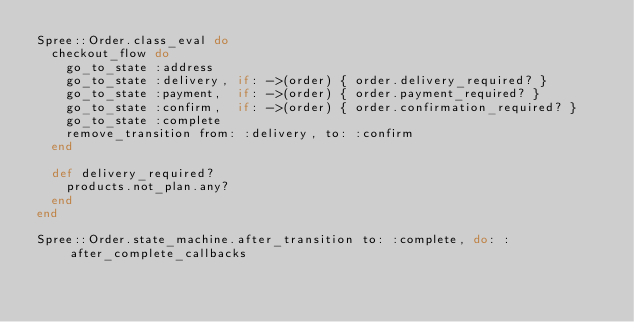<code> <loc_0><loc_0><loc_500><loc_500><_Ruby_>Spree::Order.class_eval do
  checkout_flow do
    go_to_state :address
    go_to_state :delivery, if: ->(order) { order.delivery_required? }
    go_to_state :payment,  if: ->(order) { order.payment_required? }
    go_to_state :confirm,  if: ->(order) { order.confirmation_required? }
    go_to_state :complete
    remove_transition from: :delivery, to: :confirm
  end

  def delivery_required?
    products.not_plan.any?
  end
end

Spree::Order.state_machine.after_transition to: :complete, do: :after_complete_callbacks

</code> 